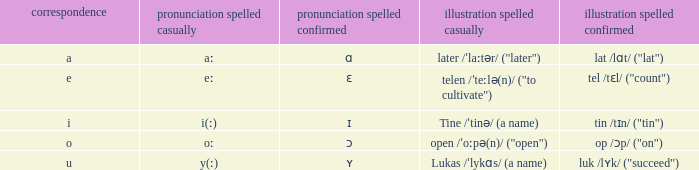What is Pronunciation Spelled Free, when Pronunciation Spelled Checked is "ʏ"? Y(ː). 